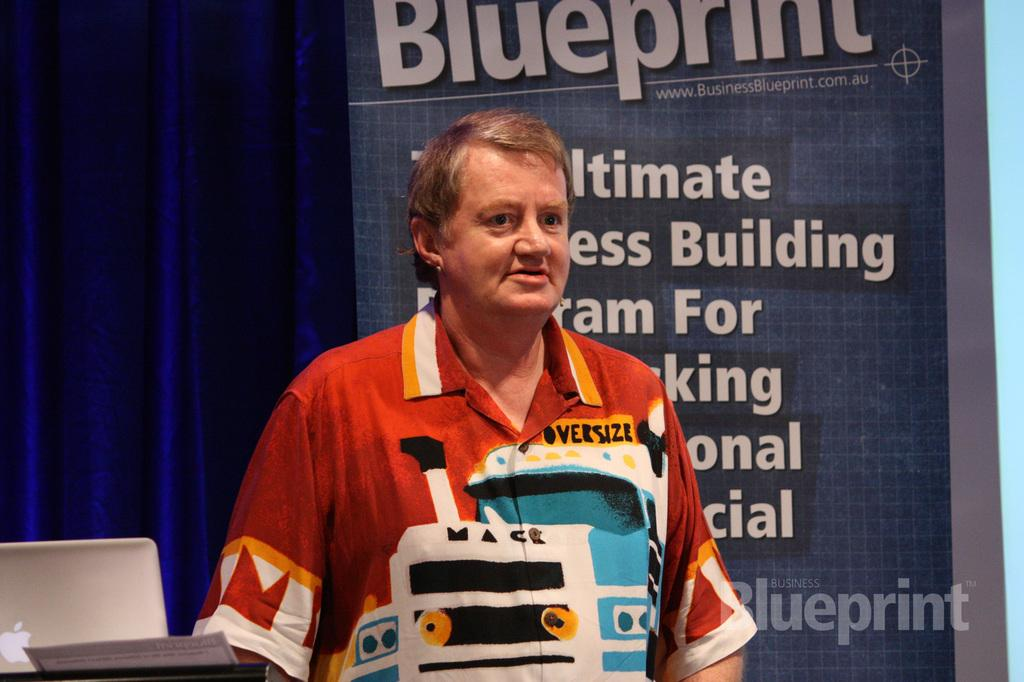<image>
Relay a brief, clear account of the picture shown. A man stands at a conference, behind him is a poster which at the top reads, Blueprint. 